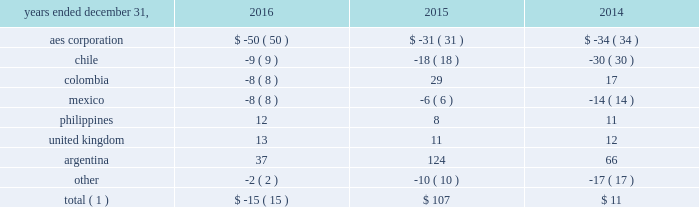The net decrease in the 2016 effective tax rate was due , in part , to the 2016 asset impairments in the u.s .
And to the current year benefit related to a restructuring of one of our brazilian businesses that increases tax basis in long-term assets .
Further , the 2015 rate was impacted by the items described below .
See note 20 2014asset impairment expense for additional information regarding the 2016 u.s .
Asset impairments .
Income tax expense increased $ 101 million , or 27% ( 27 % ) , to $ 472 million in 2015 .
The company's effective tax rates were 41% ( 41 % ) and 26% ( 26 % ) for the years ended december 31 , 2015 and 2014 , respectively .
The net increase in the 2015 effective tax rate was due , in part , to the nondeductible 2015 impairment of goodwill at our u.s .
Utility , dp&l and chilean withholding taxes offset by the release of valuation allowance at certain of our businesses in brazil , vietnam and the u.s .
Further , the 2014 rate was impacted by the sale of approximately 45% ( 45 % ) of the company 2019s interest in masin aes pte ltd. , which owns the company 2019s business interests in the philippines and the 2014 sale of the company 2019s interests in four u.k .
Wind operating projects .
Neither of these transactions gave rise to income tax expense .
See note 15 2014equity for additional information regarding the sale of approximately 45% ( 45 % ) of the company 2019s interest in masin-aes pte ltd .
See note 23 2014dispositions for additional information regarding the sale of the company 2019s interests in four u.k .
Wind operating projects .
Our effective tax rate reflects the tax effect of significant operations outside the u.s. , which are generally taxed at rates lower than the u.s .
Statutory rate of 35% ( 35 % ) .
A future proportionate change in the composition of income before income taxes from foreign and domestic tax jurisdictions could impact our periodic effective tax rate .
The company also benefits from reduced tax rates in certain countries as a result of satisfying specific commitments regarding employment and capital investment .
See note 21 2014income taxes for additional information regarding these reduced rates .
Foreign currency transaction gains ( losses ) foreign currency transaction gains ( losses ) in millions were as follows: .
Total ( 1 ) $ ( 15 ) $ 107 $ 11 _____________________________ ( 1 ) includes gains of $ 17 million , $ 247 million and $ 172 million on foreign currency derivative contracts for the years ended december 31 , 2016 , 2015 and 2014 , respectively .
The company recognized a net foreign currency transaction loss of $ 15 million for the year ended december 31 , 2016 primarily due to losses of $ 50 million at the aes corporation mainly due to remeasurement losses on intercompany notes , and losses on swaps and options .
This loss was partially offset by gains of $ 37 million in argentina , mainly due to the favorable impact of foreign currency derivatives related to government receivables .
The company recognized a net foreign currency transaction gain of $ 107 million for the year ended december 31 , 2015 primarily due to gains of : 2022 $ 124 million in argentina , due to the favorable impact from foreign currency derivatives related to government receivables , partially offset by losses from the devaluation of the argentine peso associated with u.s .
Dollar denominated debt , and losses at termoandes ( a u.s .
Dollar functional currency subsidiary ) primarily associated with cash and accounts receivable balances in local currency , 2022 $ 29 million in colombia , mainly due to the depreciation of the colombian peso , positively impacting chivor ( a u.s .
Dollar functional currency subsidiary ) due to liabilities denominated in colombian pesos , 2022 $ 11 million in the united kingdom , mainly due to the depreciation of the pound sterling , resulting in gains at ballylumford holdings ( a u.s .
Dollar functional currency subsidiary ) associated with intercompany notes payable denominated in pound sterling , and .
What was the change in millions between 2015 and 2016 of foreign currency transaction gains ( losses ) for aes corporation? 
Computations: (-50 - -31)
Answer: -19.0. 